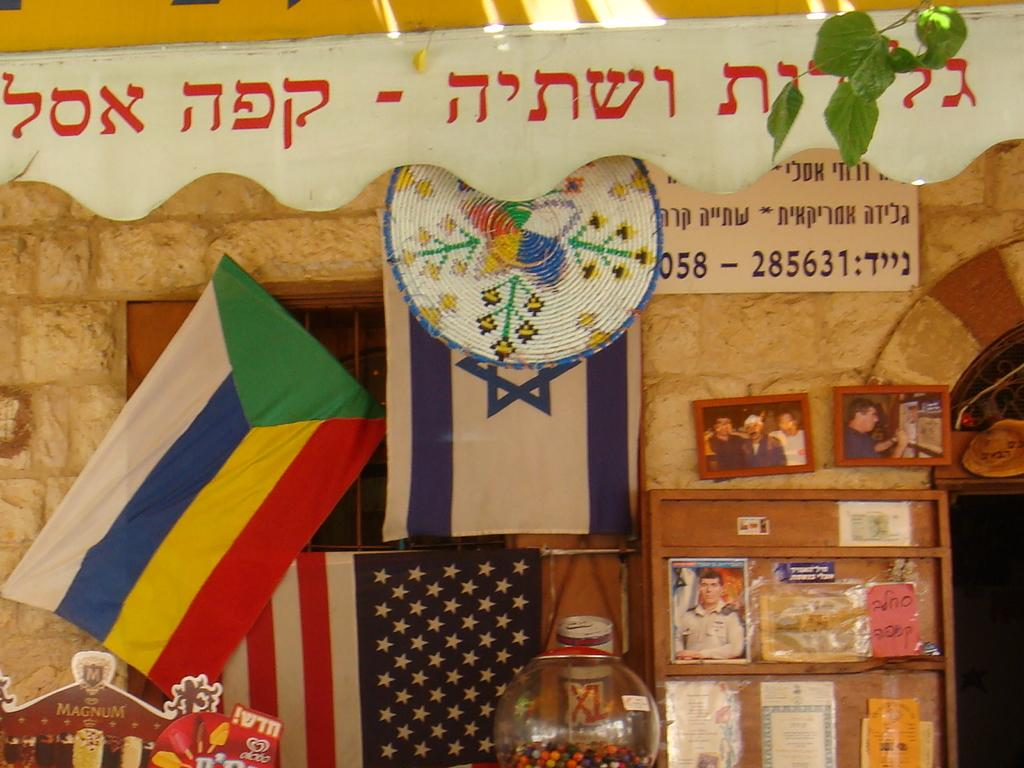What is hanging on the wall in the image? There are photo frames on the wall. What is attached to the wooden board in the image? There are posters on a wooden board. What type of decorations are present in the image? Flags are present in the image. What type of natural elements can be seen in the image? Leaves are visible in the image. What can be described as objects in the image? There are objects in the image. What type of coat is the minister wearing while begging in the image? There is no minister, coat, or begging depicted in the image. What type of beggar can be seen holding a coat in the image? There is no beggar or coat present in the image. 